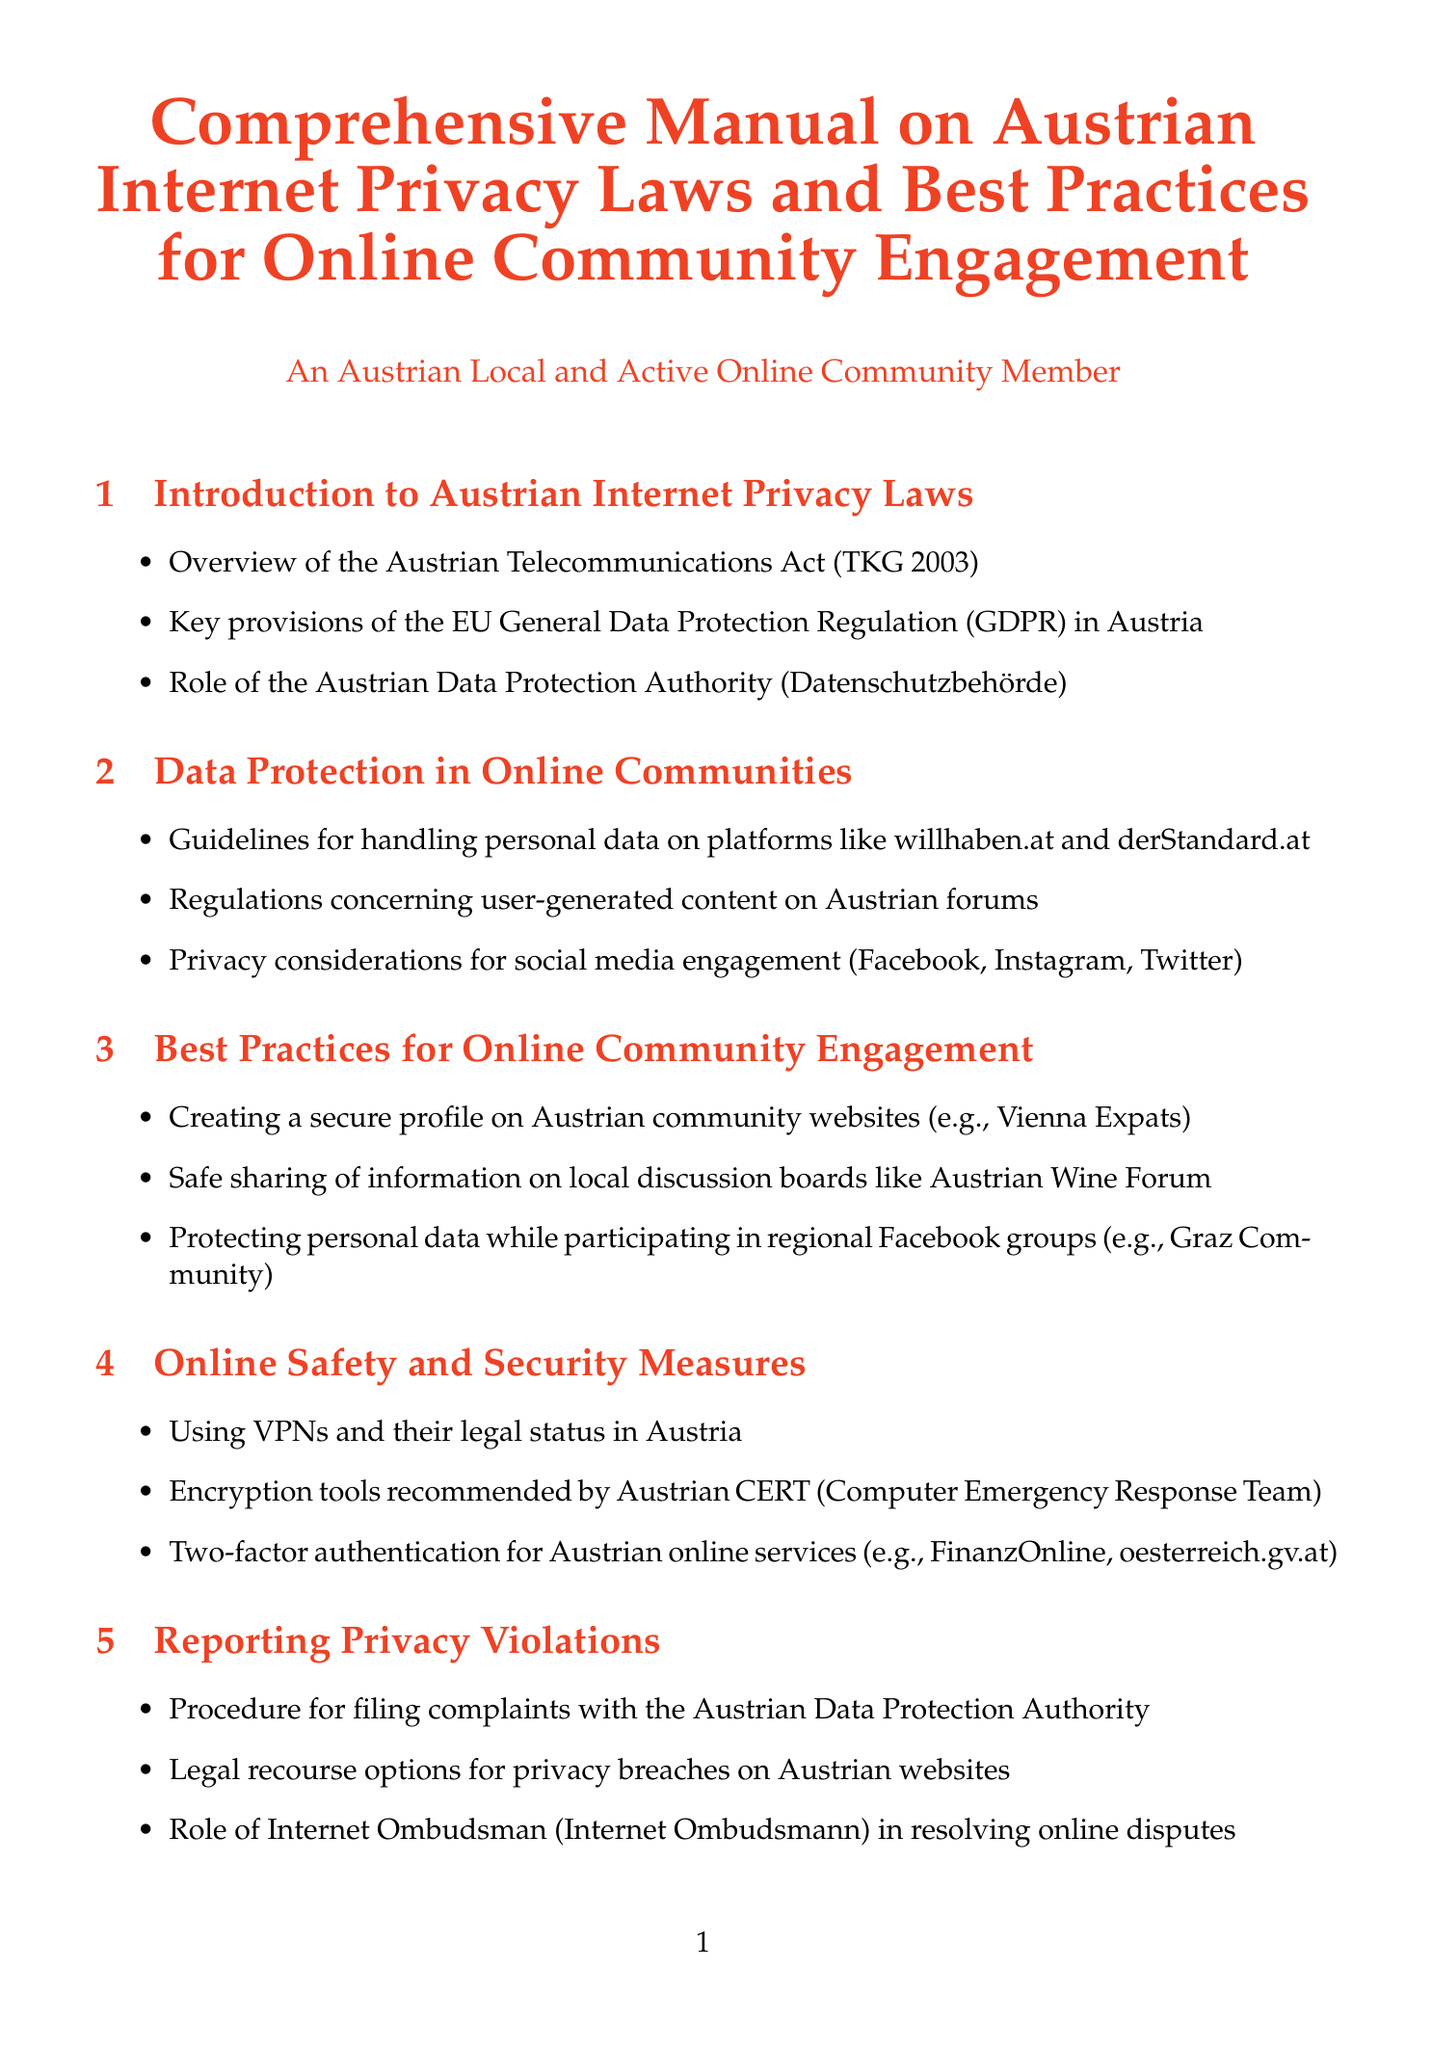What is the main legislation discussed in the introduction? The introduction discusses the Austrian Telecommunications Act (TKG 2003) as a key piece of legislation.
Answer: Austrian Telecommunications Act (TKG 2003) What is the role of Datenschutzbehörde? The document mentions that the Austrian Data Protection Authority (Datenschutzbehörde) is significant in the context of internet privacy laws in Austria.
Answer: Oversight of data protection laws What are the privacy considerations mentioned for social media? Privacy considerations specifically for major social media platforms are addressed in the guidelines for data protection in online communities.
Answer: Facebook, Instagram, Twitter Which security measure is recommended for online services? The document recommends the use of two-factor authentication for added security on specific Austrian online services.
Answer: Two-factor authentication What is the procedure for filing complaints? The manual describes a procedure that individuals can follow to report privacy violations to the appropriate authority.
Answer: Filing complaints with the Austrian Data Protection Authority Which case is analyzed in the case studies? Analysis of a notable legal case involving privacy and data protection in Austria is included in the case studies section.
Answer: Max Schrems vs. Facebook What is a potential future change mentioned in the document? The document discusses proposed amendments to the Austrian Telecommunications Act as a potential future change in internet privacy laws.
Answer: Proposed amendments to the Austrian Telecommunications Act What type of website is mentioned as a resource? The manual includes mentions of various official websites and advocacy groups relevant to internet privacy in Austria.
Answer: Bundesministerium für Digitalisierung und Wirtschaftsstandort What does the manual suggest about using VPNs? The document addresses the status and legal considerations associated with using VPNs in Austria within the online safety section.
Answer: Using VPNs and their legal status in Austria 